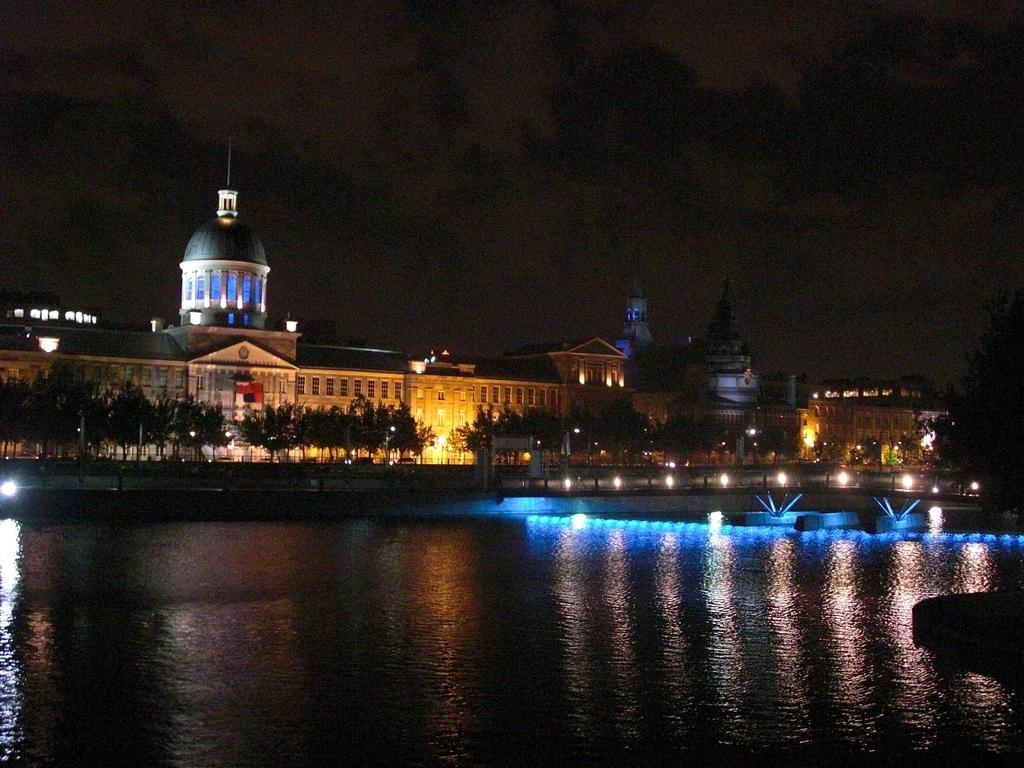What is the primary element visible in the image? There is water in the image. What other natural elements can be seen in the image? There are trees in the image. Are there any man-made structures visible? Yes, there are buildings with windows in the image. What can be seen in the background of the image? The sky is visible in the background of the image. How many farms are visible in the image? There are no farms present in the image. What is the size of the water in the image? The size of the water cannot be determined from the image alone, as there is no reference point for comparison. 